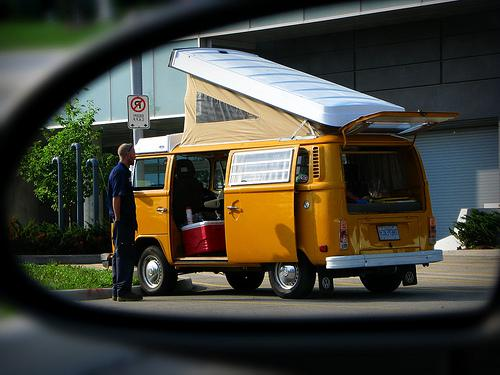Question: what is the color of the truck?
Choices:
A. Red.
B. Yellow.
C. Primer.
D. Brown.
Answer with the letter. Answer: B Question: who is reflected in the mirror?
Choices:
A. He who looks in mirror.
B. Yourself.
C. The man.
D. You.
Answer with the letter. Answer: C Question: why is the truck open?
Choices:
A. To sell his wares.
B. To fill with fruit.
C. It's a hot day.
D. Fill with boxes.
Answer with the letter. Answer: C Question: what color are the truck handles?
Choices:
A. Silver.
B. Black.
C. Gold.
D. White.
Answer with the letter. Answer: A Question: how many tires are on the truck?
Choices:
A. Three.
B. Five.
C. Four.
D. Six.
Answer with the letter. Answer: C Question: what sign is above the truck?
Choices:
A. Handicapped.
B. Cars next lane over.
C. No parking.
D. Trucks only.
Answer with the letter. Answer: C 